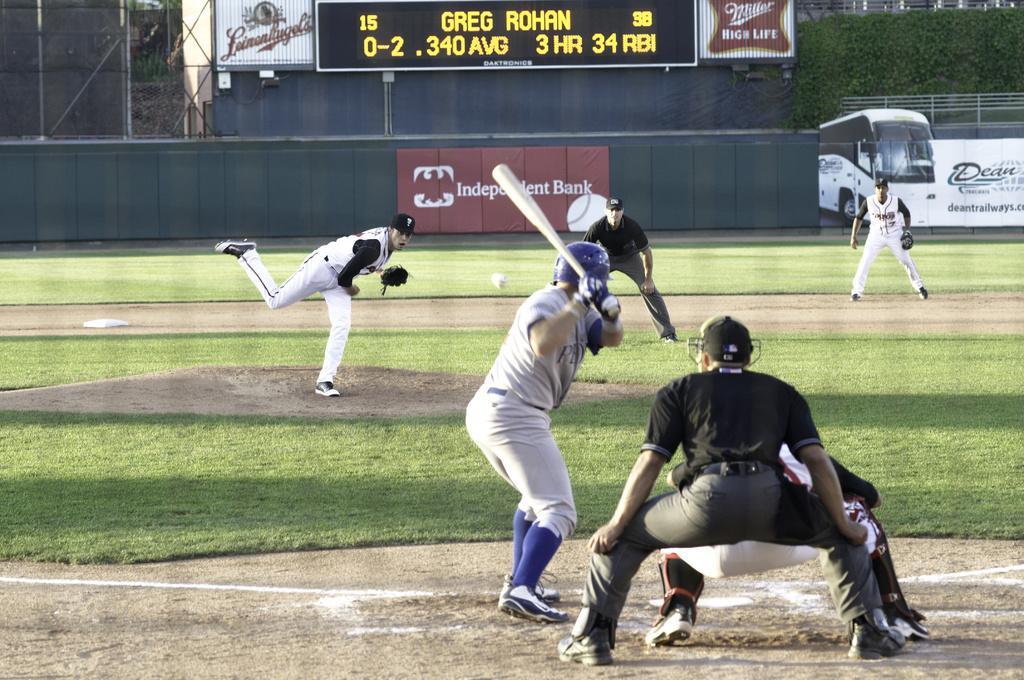Please provide a concise description of this image. In this image, we can see persons wearing clothes and playing baseball. There is a person in the middle of the image holding a bat with his hands. There is a screen at the top of the image. There are climbing plants in the top right of the image. 